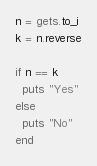<code> <loc_0><loc_0><loc_500><loc_500><_Ruby_>n = gets.to_i
k = n.reverse

if n == k
  puts "Yes"
else
  puts "No"
end
</code> 